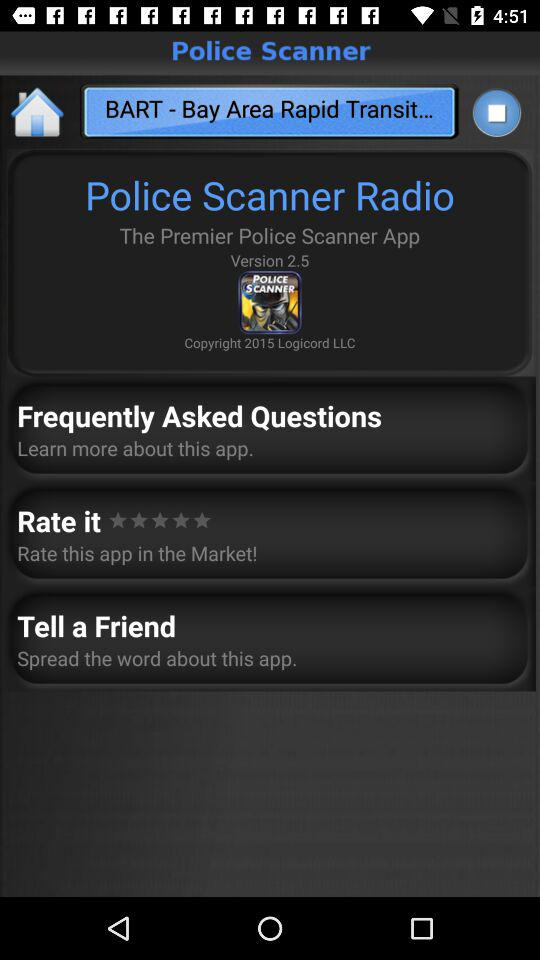What is the application name? The application name is "Police Scanner". 